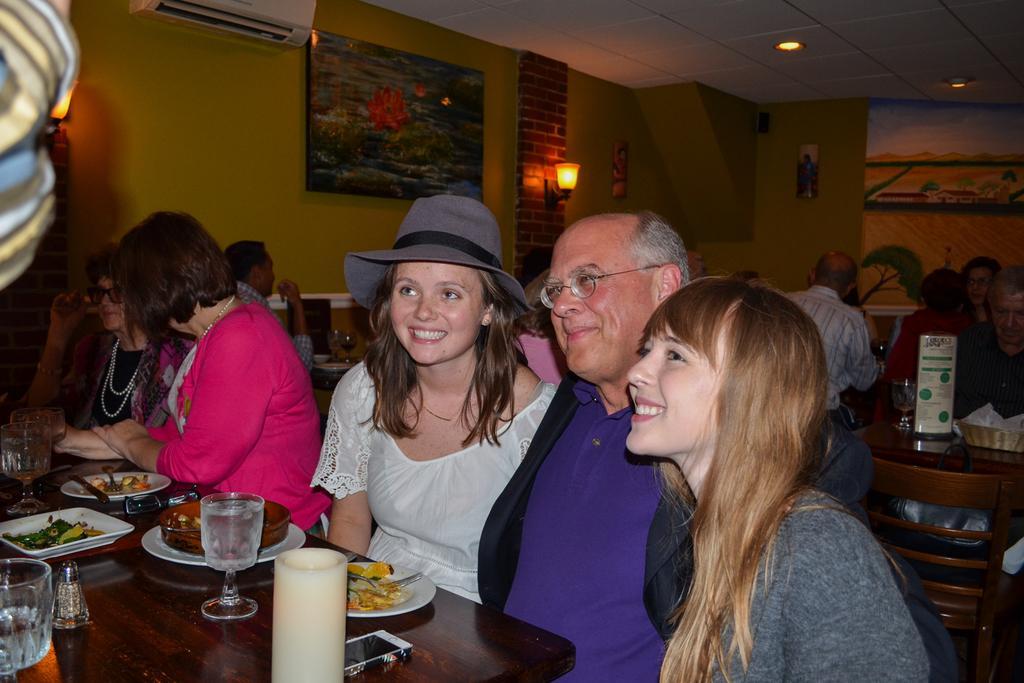Please provide a concise description of this image. There are five persons sitting in a row. Four of the are women and other one is men. In front them, there is a glass, plates, candle, mobile and other items on the table. In the background, there is poster and air conditioner on the wall, light, roof, photo frame on the wall and other person sitting on the chairs. 